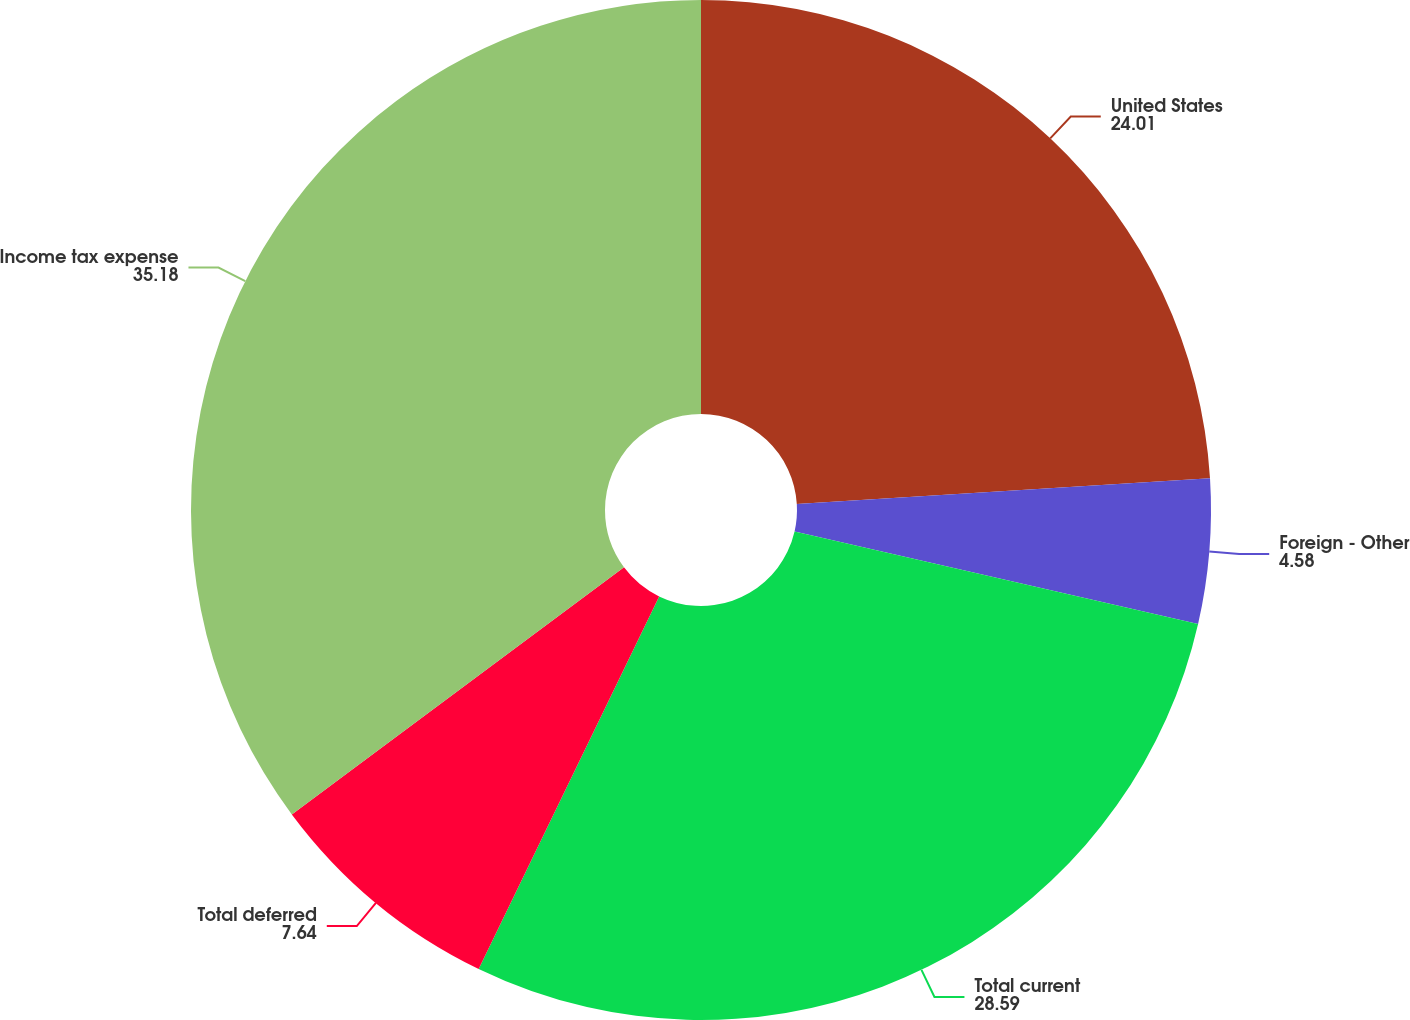<chart> <loc_0><loc_0><loc_500><loc_500><pie_chart><fcel>United States<fcel>Foreign - Other<fcel>Total current<fcel>Total deferred<fcel>Income tax expense<nl><fcel>24.01%<fcel>4.58%<fcel>28.59%<fcel>7.64%<fcel>35.18%<nl></chart> 